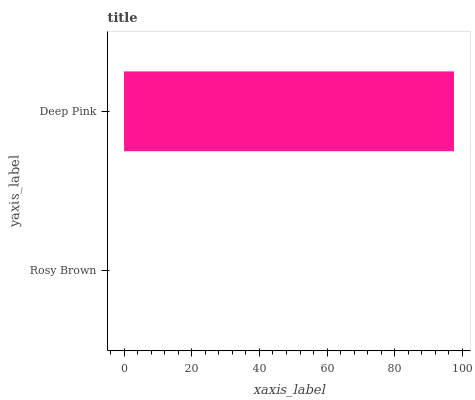Is Rosy Brown the minimum?
Answer yes or no. Yes. Is Deep Pink the maximum?
Answer yes or no. Yes. Is Deep Pink the minimum?
Answer yes or no. No. Is Deep Pink greater than Rosy Brown?
Answer yes or no. Yes. Is Rosy Brown less than Deep Pink?
Answer yes or no. Yes. Is Rosy Brown greater than Deep Pink?
Answer yes or no. No. Is Deep Pink less than Rosy Brown?
Answer yes or no. No. Is Deep Pink the high median?
Answer yes or no. Yes. Is Rosy Brown the low median?
Answer yes or no. Yes. Is Rosy Brown the high median?
Answer yes or no. No. Is Deep Pink the low median?
Answer yes or no. No. 